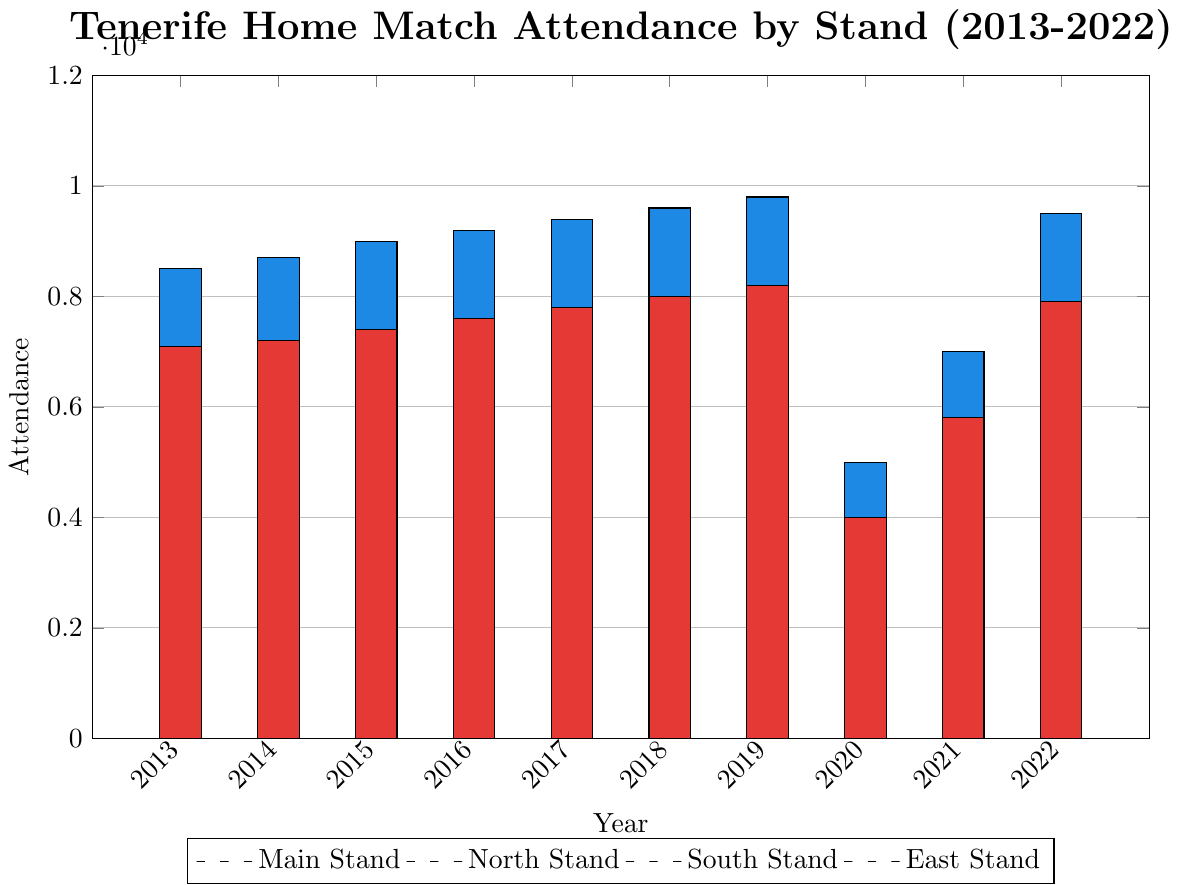What stand had the highest attendance in 2019? By looking at the bar heights for 2019, the Main Stand has the highest bar among the stands.
Answer: Main Stand How did the attendance in the North Stand change between 2019 and 2020? In 2019, North Stand's attendance was 7300, and in 2020, it was 3500. The attendance dropped by 3800.
Answer: Dropped by 3800 What was the total attendance for all stands in 2021? Adding the attendance from all stands in 2021: 7000 (Main Stand) + 5000 (North Stand) + 4800 (South Stand) + 5800 (East Stand) gives 22600.
Answer: 22600 Which year showed the lowest attendance for the South Stand? By comparing the bar heights for the South Stand across all years, 2020 had the smallest bar.
Answer: 2020 How did the attendance in the Main Stand change overall from 2013 to 2022? Initially, in 2013 the Main Stand's attendance was 8500, and by 2022 it was 9500, showing an overall increase.
Answer: Increased by 1000 Which stand consistently had the lowest attendance from 2013 to 2019? Comparing the heights of the bars for each stand from 2013 to 2019, the South Stand consistently had the lowest attendance.
Answer: South Stand In which year did the East Stand see its highest attendance? By examining the bar heights for the East Stand, the highest bar is in 2019, indicating the highest attendance.
Answer: 2019 In 2020, what was the difference in attendance between the Main Stand and the East Stand? The attendance in 2020 for the Main Stand is 5000, and for the East Stand is 4000. The difference is 1000.
Answer: 1000 How much higher was the total attendance in 2019 compared to 2018? Total attendance in 2019 is: 9800 (Main) + 7300 (North) + 6900 (South) + 8200 (East) = 32200. Total attendance in 2018 is: 9600 (Main) + 7100 (North) + 6700 (South) + 8000 (East) = 31400. The difference is 800.
Answer: 800 